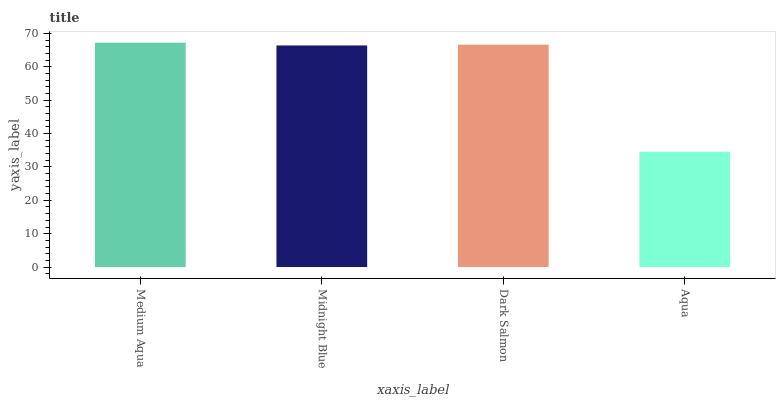Is Aqua the minimum?
Answer yes or no. Yes. Is Medium Aqua the maximum?
Answer yes or no. Yes. Is Midnight Blue the minimum?
Answer yes or no. No. Is Midnight Blue the maximum?
Answer yes or no. No. Is Medium Aqua greater than Midnight Blue?
Answer yes or no. Yes. Is Midnight Blue less than Medium Aqua?
Answer yes or no. Yes. Is Midnight Blue greater than Medium Aqua?
Answer yes or no. No. Is Medium Aqua less than Midnight Blue?
Answer yes or no. No. Is Dark Salmon the high median?
Answer yes or no. Yes. Is Midnight Blue the low median?
Answer yes or no. Yes. Is Medium Aqua the high median?
Answer yes or no. No. Is Medium Aqua the low median?
Answer yes or no. No. 